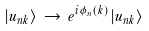<formula> <loc_0><loc_0><loc_500><loc_500>| u _ { n { k } } \rangle \, \rightarrow \, e ^ { i \phi _ { n } ( { k } ) } | u _ { n { k } } \rangle</formula> 